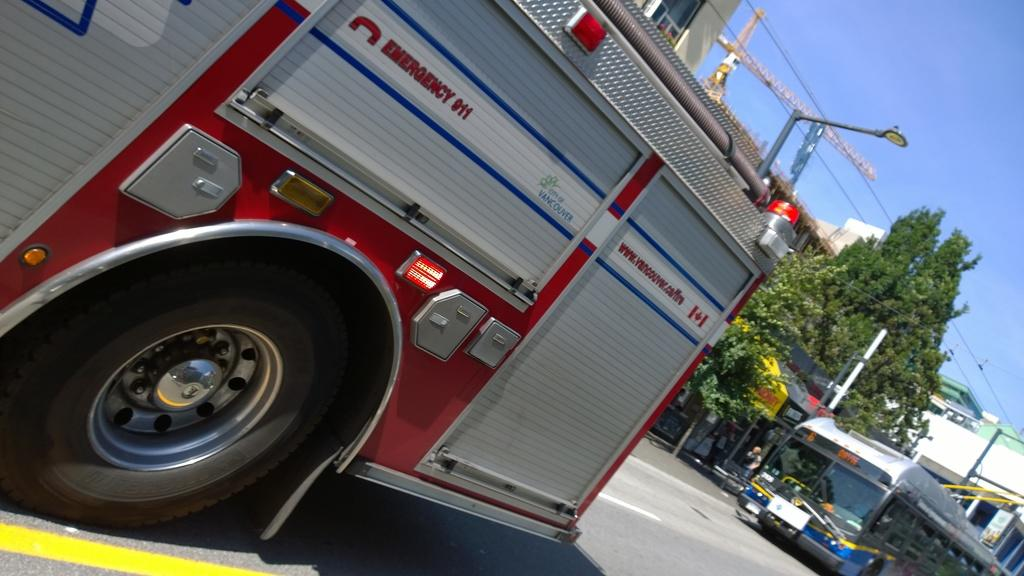What can be seen on the road in the image? There are vehicles on the road in the image. What type of natural elements are present in the image? There are trees in the image. What type of man-made structures can be seen in the image? There are buildings in the image. What type of infrastructure is present in the image? There are wires and a pole in the image. Are there any people visible in the image? Yes, there are persons standing in the image. What is visible in the background of the image? The sky is visible in the background of the image. What type of pencil can be seen in the image? There is no pencil present in the image. What type of waste is being disposed of in the image? There is no waste disposal visible in the image. 